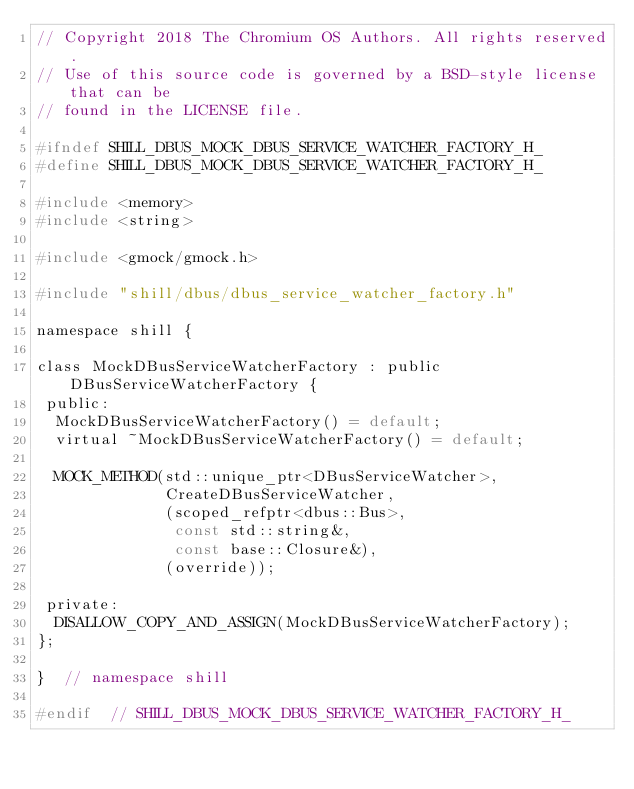<code> <loc_0><loc_0><loc_500><loc_500><_C_>// Copyright 2018 The Chromium OS Authors. All rights reserved.
// Use of this source code is governed by a BSD-style license that can be
// found in the LICENSE file.

#ifndef SHILL_DBUS_MOCK_DBUS_SERVICE_WATCHER_FACTORY_H_
#define SHILL_DBUS_MOCK_DBUS_SERVICE_WATCHER_FACTORY_H_

#include <memory>
#include <string>

#include <gmock/gmock.h>

#include "shill/dbus/dbus_service_watcher_factory.h"

namespace shill {

class MockDBusServiceWatcherFactory : public DBusServiceWatcherFactory {
 public:
  MockDBusServiceWatcherFactory() = default;
  virtual ~MockDBusServiceWatcherFactory() = default;

  MOCK_METHOD(std::unique_ptr<DBusServiceWatcher>,
              CreateDBusServiceWatcher,
              (scoped_refptr<dbus::Bus>,
               const std::string&,
               const base::Closure&),
              (override));

 private:
  DISALLOW_COPY_AND_ASSIGN(MockDBusServiceWatcherFactory);
};

}  // namespace shill

#endif  // SHILL_DBUS_MOCK_DBUS_SERVICE_WATCHER_FACTORY_H_
</code> 